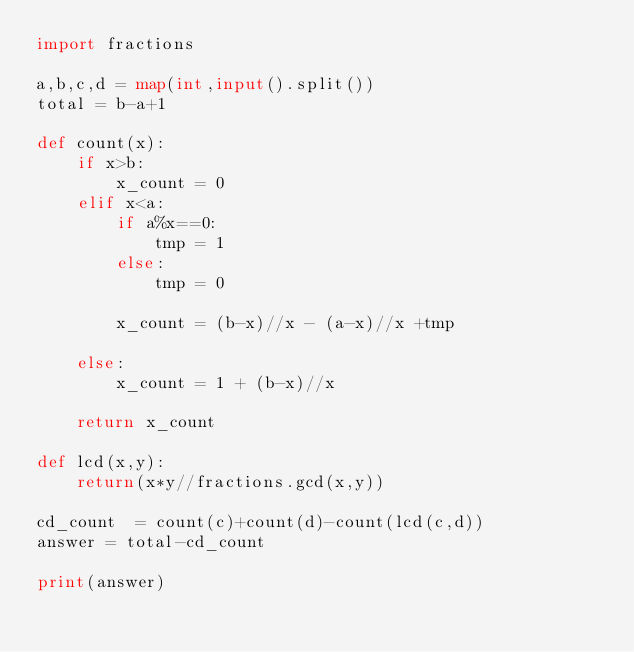Convert code to text. <code><loc_0><loc_0><loc_500><loc_500><_Python_>import fractions

a,b,c,d = map(int,input().split())
total = b-a+1

def count(x):
    if x>b:
        x_count = 0
    elif x<a:
        if a%x==0:
            tmp = 1
        else:
            tmp = 0

        x_count = (b-x)//x - (a-x)//x +tmp

    else:
        x_count = 1 + (b-x)//x

    return x_count

def lcd(x,y):
    return(x*y//fractions.gcd(x,y))

cd_count  = count(c)+count(d)-count(lcd(c,d))
answer = total-cd_count

print(answer)</code> 